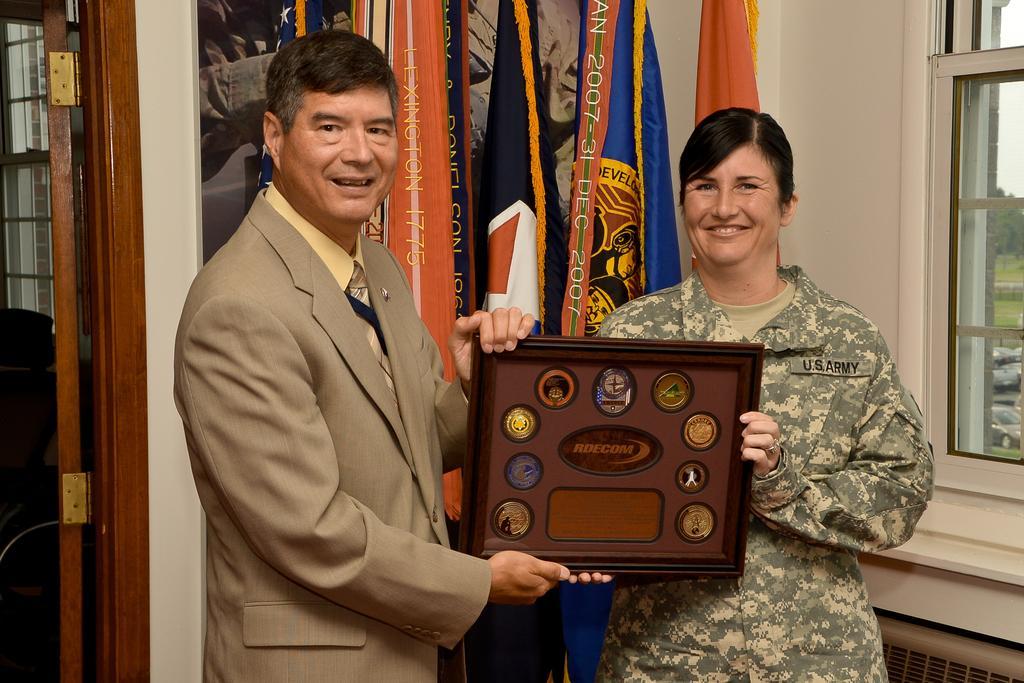Describe this image in one or two sentences. In this image we can see a man and a woman standing on the floor holding a momento. On the backside we can see the flags, a painting on a wall and a door. 